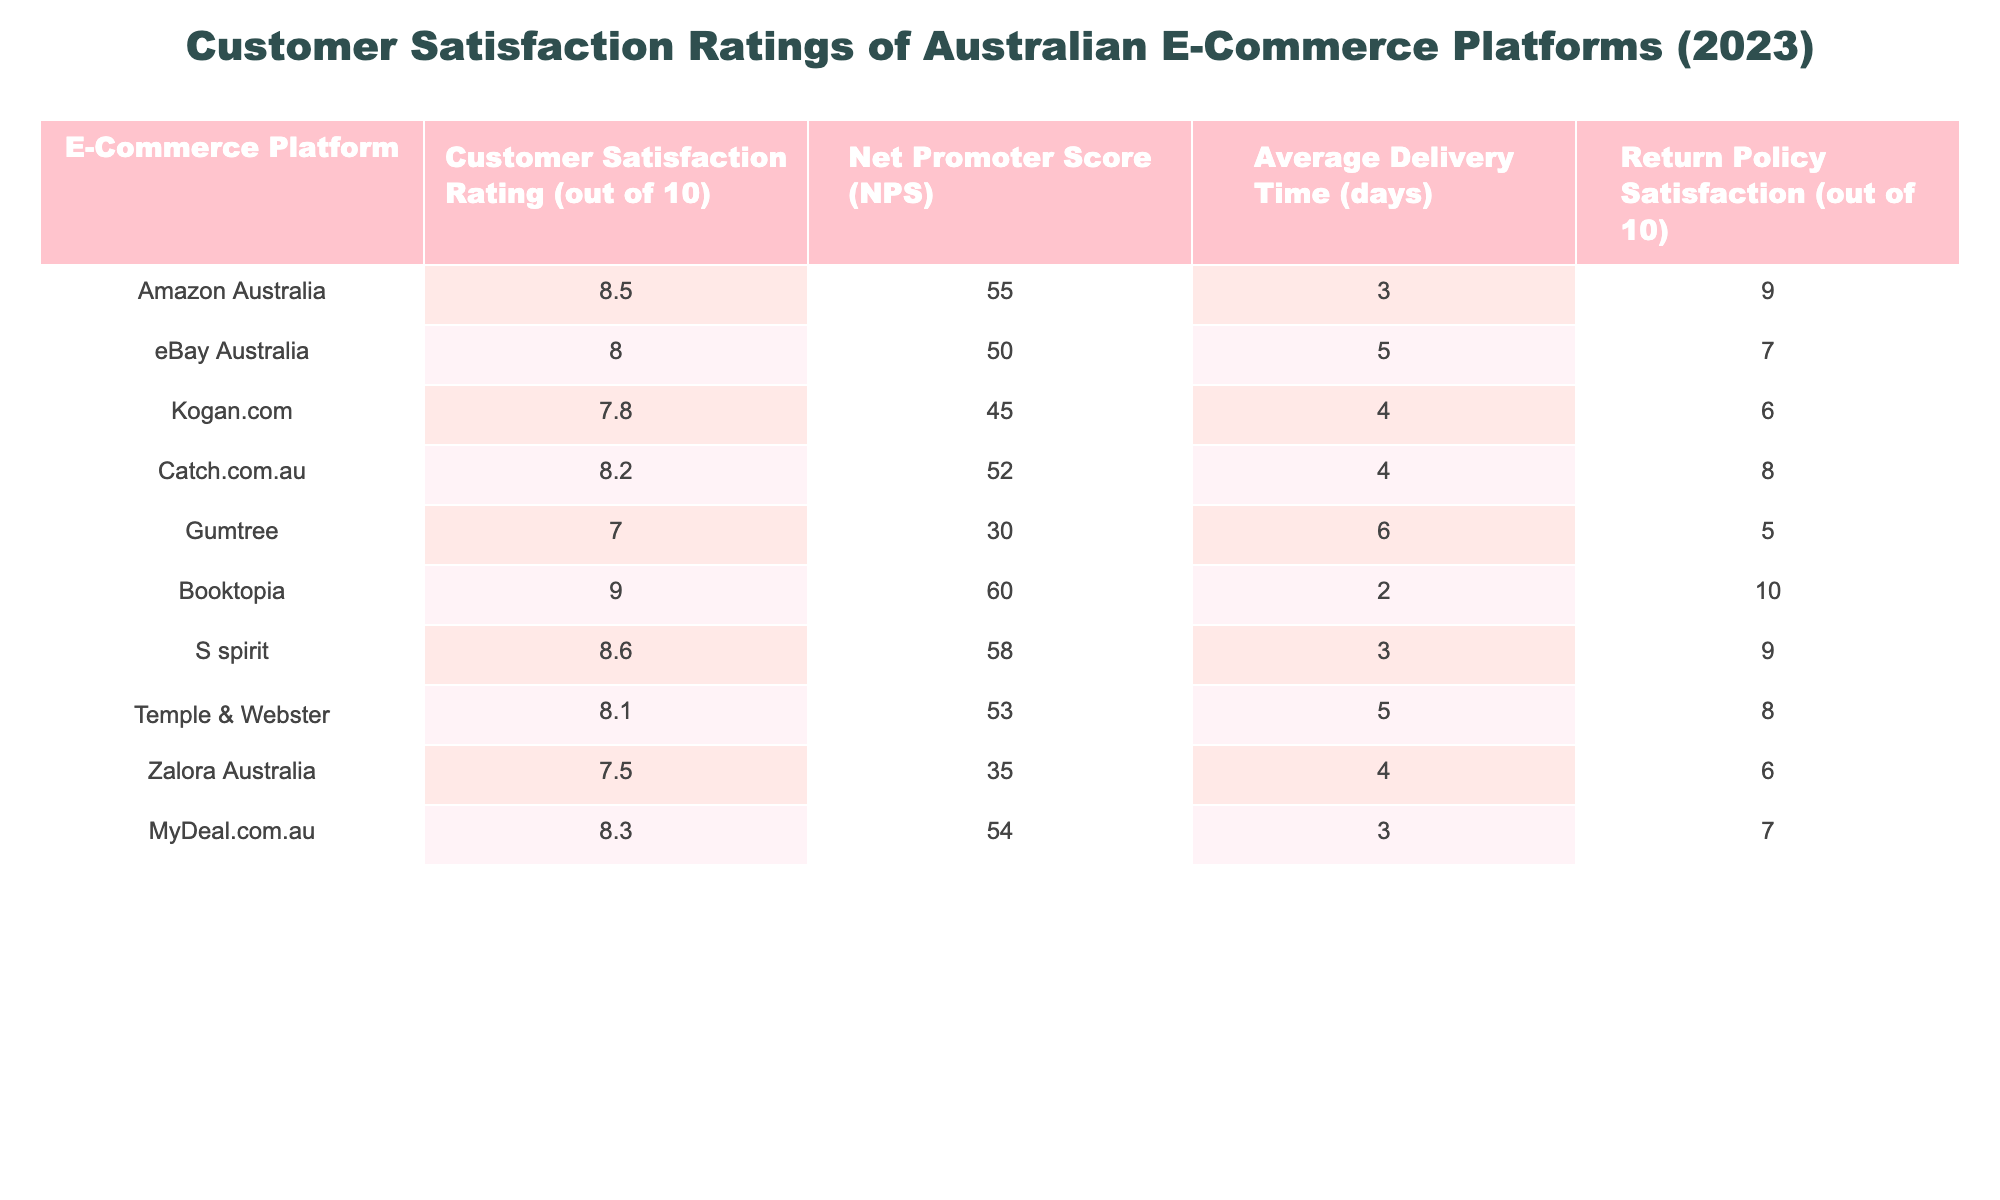What is the customer satisfaction rating of Booktopia? The table shows that Booktopia has a customer satisfaction rating of 9.0 out of 10.
Answer: 9.0 Which e-commerce platform has the highest Net Promoter Score? From the table, Booktopia has the highest Net Promoter Score at 60.
Answer: Booktopia What is the average delivery time for Kogan.com? The table indicates that Kogan.com has an average delivery time of 4 days.
Answer: 4 days Is the return policy satisfaction for Catch.com.au greater than 7? The table shows that Catch.com.au has a return policy satisfaction score of 8, which is greater than 7.
Answer: Yes What is the difference between the customer satisfaction ratings of Amazon Australia and Gumtree? Amazon Australia has a rating of 8.5 and Gumtree has a rating of 7.0. The difference is 8.5 - 7.0 = 1.5.
Answer: 1.5 Which e-commerce platform has the lowest customer satisfaction rating, and what is that rating? The table indicates that Gumtree has the lowest customer satisfaction rating of 7.0 out of 10.
Answer: Gumtree, 7.0 What is the average customer satisfaction rating for the e-commerce platforms listed? To find the average, sum all the ratings (8.5 + 8.0 + 7.8 + 8.2 + 7.0 + 9.0 + 8.6 + 8.1 + 7.5 + 8.3 = 8.23), then divide by 10. Therefore, the average rating is 8.23.
Answer: 8.23 Does Zalora Australia have a higher average delivery time than Temple & Webster? Zalora has an average delivery time of 4 days and Temple & Webster has 5 days; since 4 < 5, Zalora does not have a higher delivery time.
Answer: No How many platforms have a customer satisfaction rating above 8.0? The platforms with ratings above 8.0 are Amazon Australia, Booktopia, S spirit, Catch.com.au, and MyDeal.com.au, totaling 5 platforms.
Answer: 5 platforms What is the return policy satisfaction rating of the platform with the highest Net Promoter Score? The platform with the highest Net Promoter Score is Booktopia, which has a return policy satisfaction rating of 10.
Answer: 10 